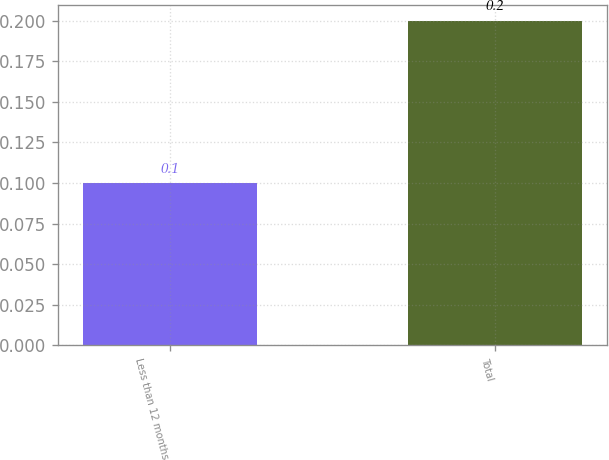<chart> <loc_0><loc_0><loc_500><loc_500><bar_chart><fcel>Less than 12 months<fcel>Total<nl><fcel>0.1<fcel>0.2<nl></chart> 